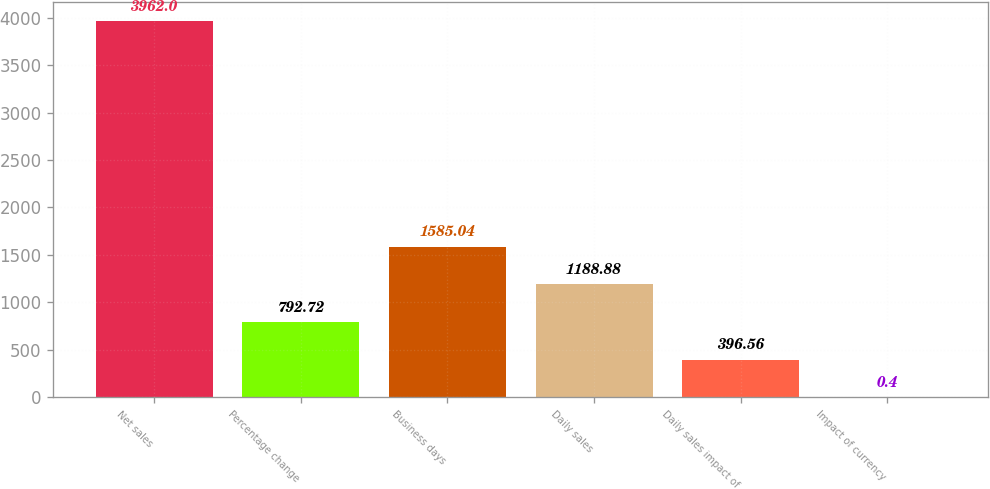<chart> <loc_0><loc_0><loc_500><loc_500><bar_chart><fcel>Net sales<fcel>Percentage change<fcel>Business days<fcel>Daily sales<fcel>Daily sales impact of<fcel>Impact of currency<nl><fcel>3962<fcel>792.72<fcel>1585.04<fcel>1188.88<fcel>396.56<fcel>0.4<nl></chart> 